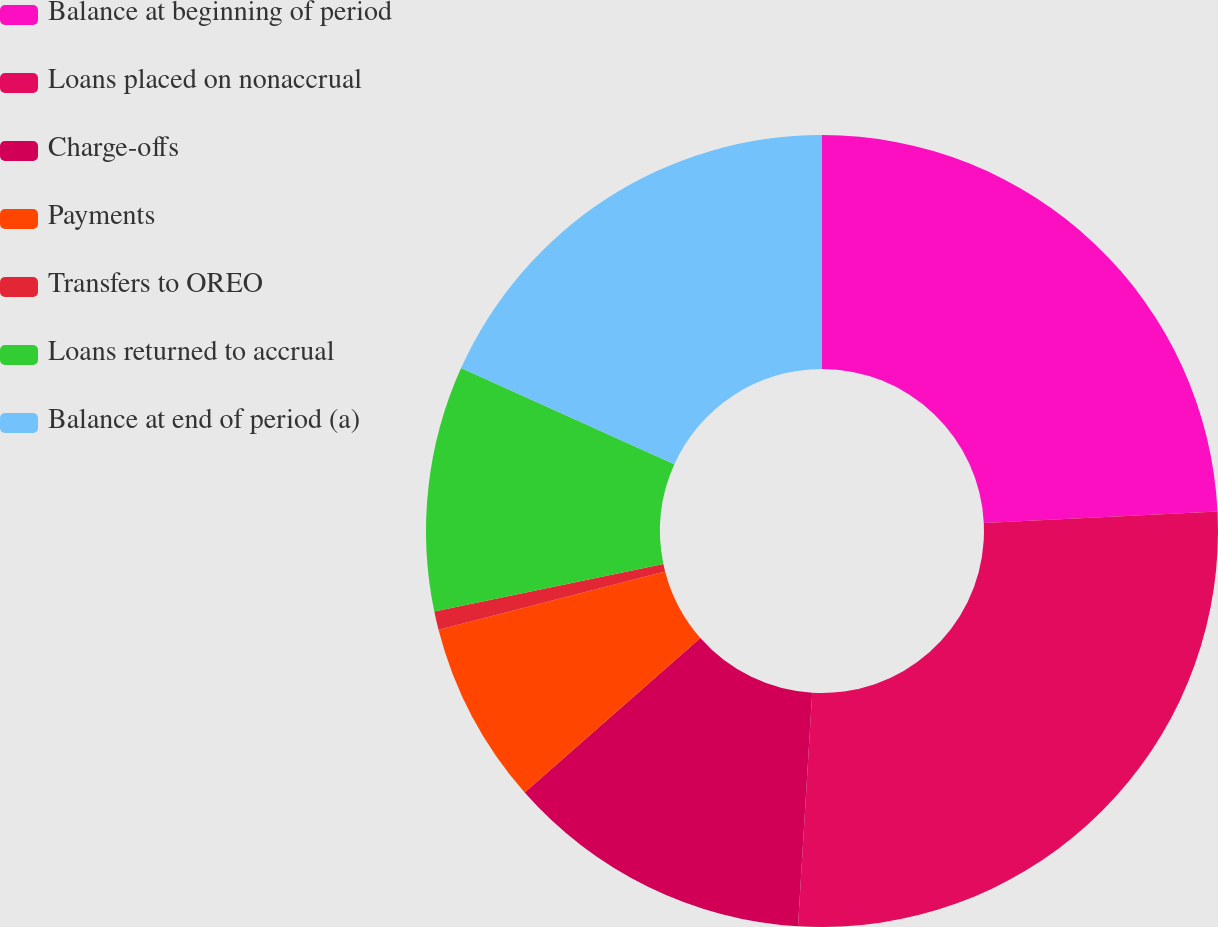<chart> <loc_0><loc_0><loc_500><loc_500><pie_chart><fcel>Balance at beginning of period<fcel>Loans placed on nonaccrual<fcel>Charge-offs<fcel>Payments<fcel>Transfers to OREO<fcel>Loans returned to accrual<fcel>Balance at end of period (a)<nl><fcel>24.21%<fcel>26.75%<fcel>12.55%<fcel>7.47%<fcel>0.75%<fcel>10.01%<fcel>18.25%<nl></chart> 